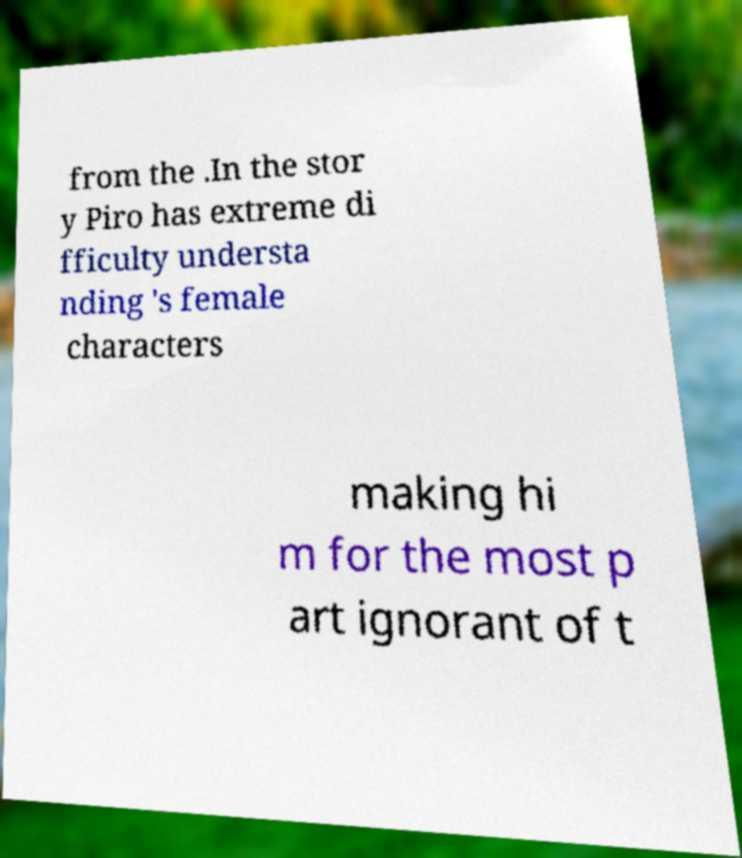Please read and relay the text visible in this image. What does it say? from the .In the stor y Piro has extreme di fficulty understa nding 's female characters making hi m for the most p art ignorant of t 